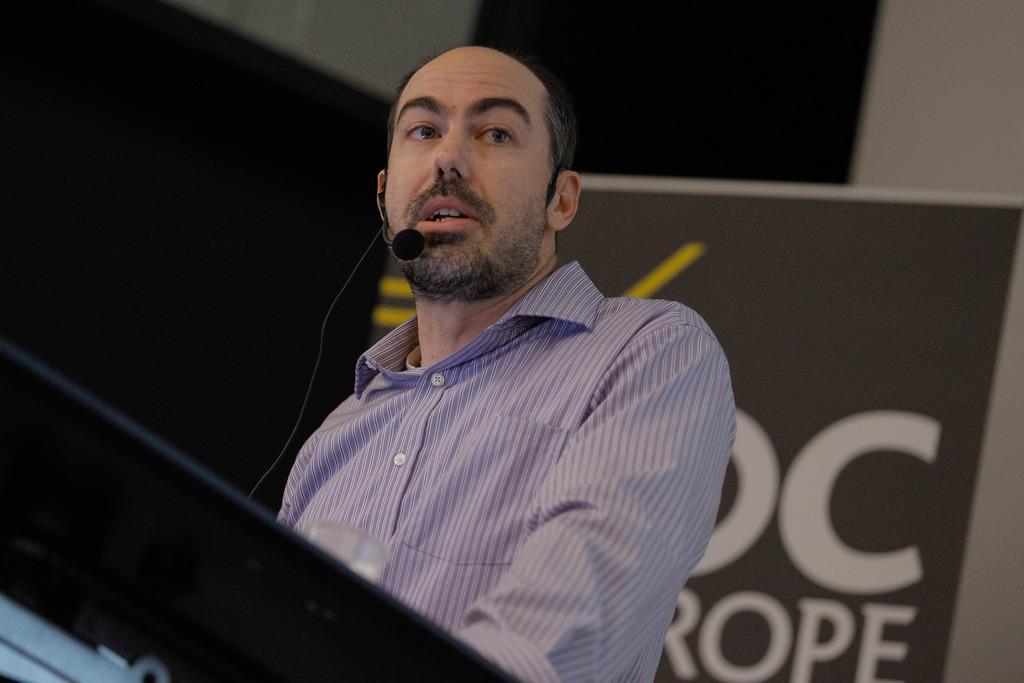In one or two sentences, can you explain what this image depicts? In this image there is a person wearing a mike. In front of him there is a podium. On top of it there is a glass. Behind him there is a banner. In the background of the image there is a wall. 